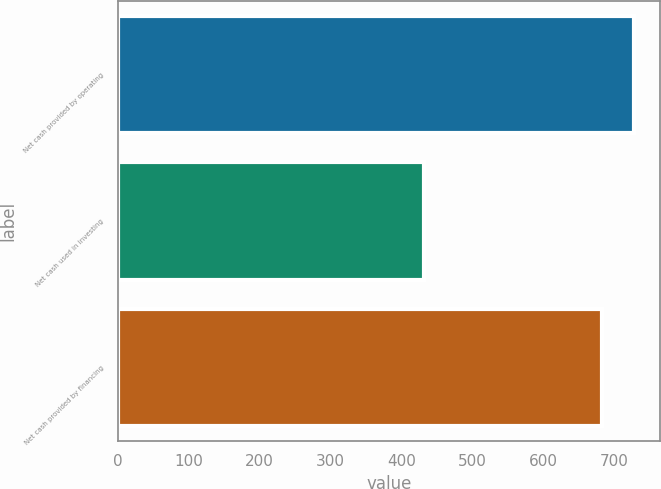<chart> <loc_0><loc_0><loc_500><loc_500><bar_chart><fcel>Net cash provided by operating<fcel>Net cash used in investing<fcel>Net cash provided by financing<nl><fcel>727.6<fcel>431.2<fcel>682.3<nl></chart> 